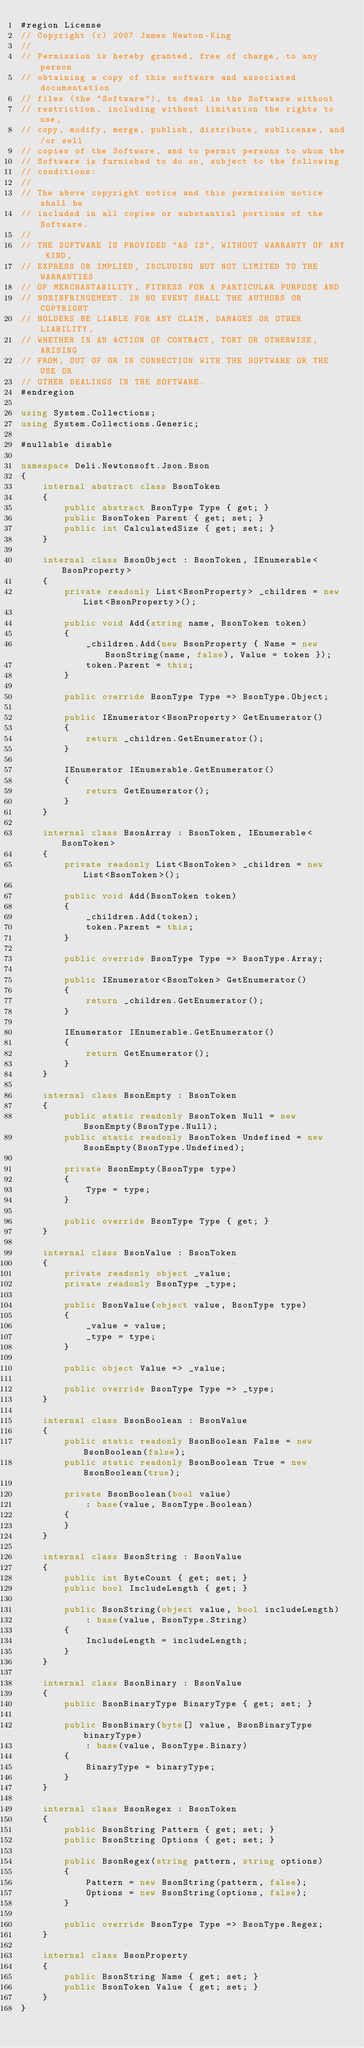Convert code to text. <code><loc_0><loc_0><loc_500><loc_500><_C#_>#region License
// Copyright (c) 2007 James Newton-King
//
// Permission is hereby granted, free of charge, to any person
// obtaining a copy of this software and associated documentation
// files (the "Software"), to deal in the Software without
// restriction, including without limitation the rights to use,
// copy, modify, merge, publish, distribute, sublicense, and/or sell
// copies of the Software, and to permit persons to whom the
// Software is furnished to do so, subject to the following
// conditions:
//
// The above copyright notice and this permission notice shall be
// included in all copies or substantial portions of the Software.
//
// THE SOFTWARE IS PROVIDED "AS IS", WITHOUT WARRANTY OF ANY KIND,
// EXPRESS OR IMPLIED, INCLUDING BUT NOT LIMITED TO THE WARRANTIES
// OF MERCHANTABILITY, FITNESS FOR A PARTICULAR PURPOSE AND
// NONINFRINGEMENT. IN NO EVENT SHALL THE AUTHORS OR COPYRIGHT
// HOLDERS BE LIABLE FOR ANY CLAIM, DAMAGES OR OTHER LIABILITY,
// WHETHER IN AN ACTION OF CONTRACT, TORT OR OTHERWISE, ARISING
// FROM, OUT OF OR IN CONNECTION WITH THE SOFTWARE OR THE USE OR
// OTHER DEALINGS IN THE SOFTWARE.
#endregion

using System.Collections;
using System.Collections.Generic;

#nullable disable

namespace Deli.Newtonsoft.Json.Bson
{
    internal abstract class BsonToken
    {
        public abstract BsonType Type { get; }
        public BsonToken Parent { get; set; }
        public int CalculatedSize { get; set; }
    }

    internal class BsonObject : BsonToken, IEnumerable<BsonProperty>
    {
        private readonly List<BsonProperty> _children = new List<BsonProperty>();

        public void Add(string name, BsonToken token)
        {
            _children.Add(new BsonProperty { Name = new BsonString(name, false), Value = token });
            token.Parent = this;
        }

        public override BsonType Type => BsonType.Object;

        public IEnumerator<BsonProperty> GetEnumerator()
        {
            return _children.GetEnumerator();
        }

        IEnumerator IEnumerable.GetEnumerator()
        {
            return GetEnumerator();
        }
    }

    internal class BsonArray : BsonToken, IEnumerable<BsonToken>
    {
        private readonly List<BsonToken> _children = new List<BsonToken>();

        public void Add(BsonToken token)
        {
            _children.Add(token);
            token.Parent = this;
        }

        public override BsonType Type => BsonType.Array;

        public IEnumerator<BsonToken> GetEnumerator()
        {
            return _children.GetEnumerator();
        }

        IEnumerator IEnumerable.GetEnumerator()
        {
            return GetEnumerator();
        }
    }

    internal class BsonEmpty : BsonToken
    {
        public static readonly BsonToken Null = new BsonEmpty(BsonType.Null);
        public static readonly BsonToken Undefined = new BsonEmpty(BsonType.Undefined);

        private BsonEmpty(BsonType type)
        {
            Type = type;
        }

        public override BsonType Type { get; }
    }

    internal class BsonValue : BsonToken
    {
        private readonly object _value;
        private readonly BsonType _type;

        public BsonValue(object value, BsonType type)
        {
            _value = value;
            _type = type;
        }

        public object Value => _value;

        public override BsonType Type => _type;
    }

    internal class BsonBoolean : BsonValue
    {
        public static readonly BsonBoolean False = new BsonBoolean(false);
        public static readonly BsonBoolean True = new BsonBoolean(true);

        private BsonBoolean(bool value)
            : base(value, BsonType.Boolean)
        {
        }
    }

    internal class BsonString : BsonValue
    {
        public int ByteCount { get; set; }
        public bool IncludeLength { get; }

        public BsonString(object value, bool includeLength)
            : base(value, BsonType.String)
        {
            IncludeLength = includeLength;
        }
    }

    internal class BsonBinary : BsonValue
    {
        public BsonBinaryType BinaryType { get; set; }

        public BsonBinary(byte[] value, BsonBinaryType binaryType)
            : base(value, BsonType.Binary)
        {
            BinaryType = binaryType;
        }
    }

    internal class BsonRegex : BsonToken
    {
        public BsonString Pattern { get; set; }
        public BsonString Options { get; set; }

        public BsonRegex(string pattern, string options)
        {
            Pattern = new BsonString(pattern, false);
            Options = new BsonString(options, false);
        }

        public override BsonType Type => BsonType.Regex;
    }

    internal class BsonProperty
    {
        public BsonString Name { get; set; }
        public BsonToken Value { get; set; }
    }
}
</code> 